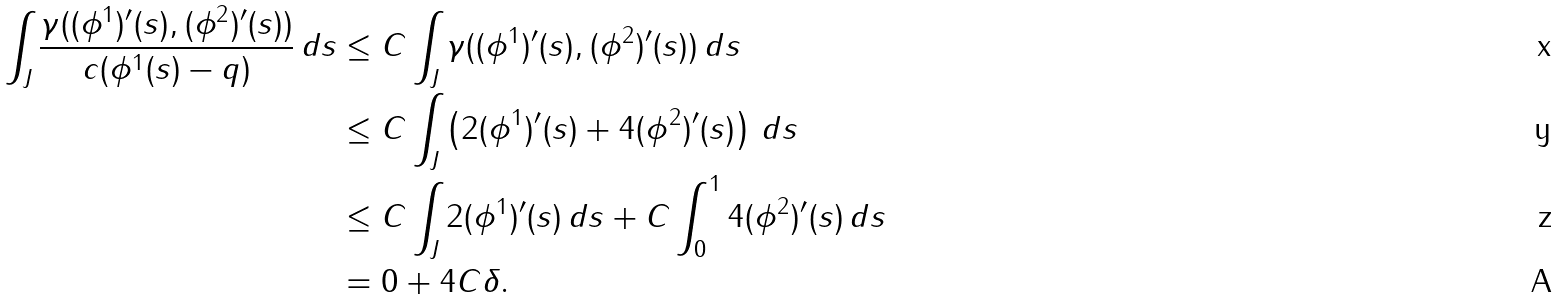<formula> <loc_0><loc_0><loc_500><loc_500>\int _ { J } \frac { \gamma ( ( \phi ^ { 1 } ) ^ { \prime } ( s ) , ( \phi ^ { 2 } ) ^ { \prime } ( s ) ) } { c ( \phi ^ { 1 } ( s ) - q ) } \, d s & \leq C \int _ { J } \gamma ( ( \phi ^ { 1 } ) ^ { \prime } ( s ) , ( \phi ^ { 2 } ) ^ { \prime } ( s ) ) \, d s \\ & \leq C \int _ { J } \left ( 2 ( \phi ^ { 1 } ) ^ { \prime } ( s ) + 4 ( \phi ^ { 2 } ) ^ { \prime } ( s ) \right ) \, d s \\ & \leq C \int _ { J } 2 ( \phi ^ { 1 } ) ^ { \prime } ( s ) \, d s + C \int _ { 0 } ^ { 1 } 4 ( \phi ^ { 2 } ) ^ { \prime } ( s ) \, d s \\ & = 0 + 4 C \delta .</formula> 